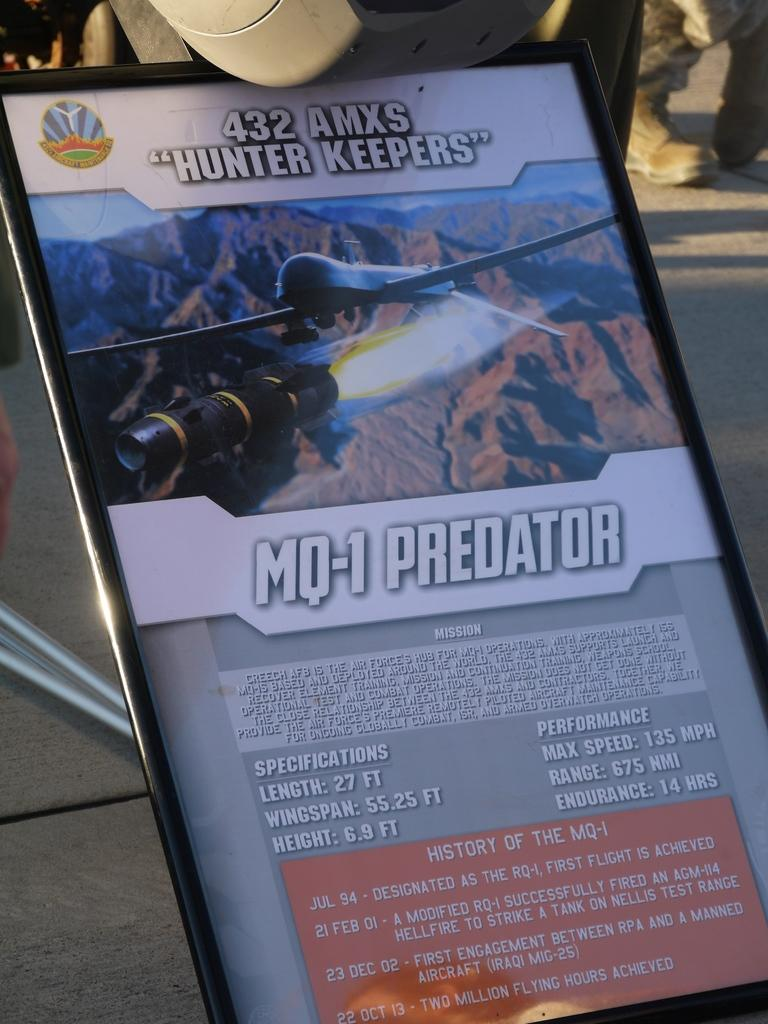<image>
Summarize the visual content of the image. The poster shows a plane and says "Hunter Keepers" 